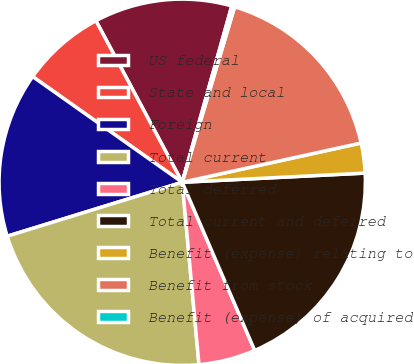<chart> <loc_0><loc_0><loc_500><loc_500><pie_chart><fcel>US federal<fcel>State and local<fcel>Foreign<fcel>Total current<fcel>Total deferred<fcel>Total current and deferred<fcel>Benefit (expense) relating to<fcel>Benefit from stock<fcel>Benefit (expense) of acquired<nl><fcel>12.17%<fcel>7.4%<fcel>14.55%<fcel>21.7%<fcel>5.02%<fcel>19.32%<fcel>2.64%<fcel>16.94%<fcel>0.26%<nl></chart> 